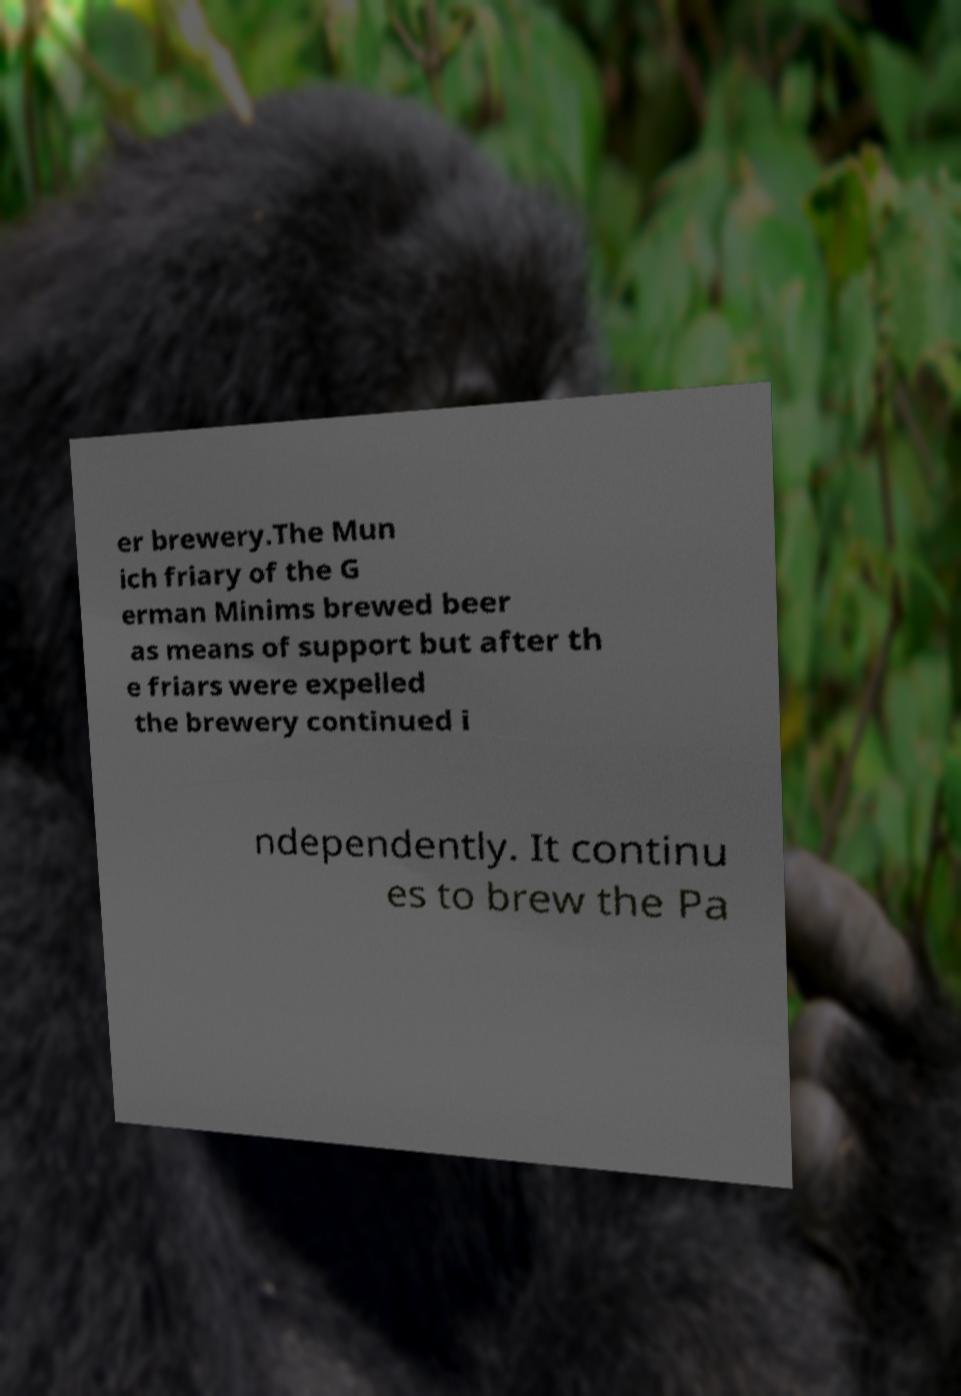For documentation purposes, I need the text within this image transcribed. Could you provide that? er brewery.The Mun ich friary of the G erman Minims brewed beer as means of support but after th e friars were expelled the brewery continued i ndependently. It continu es to brew the Pa 